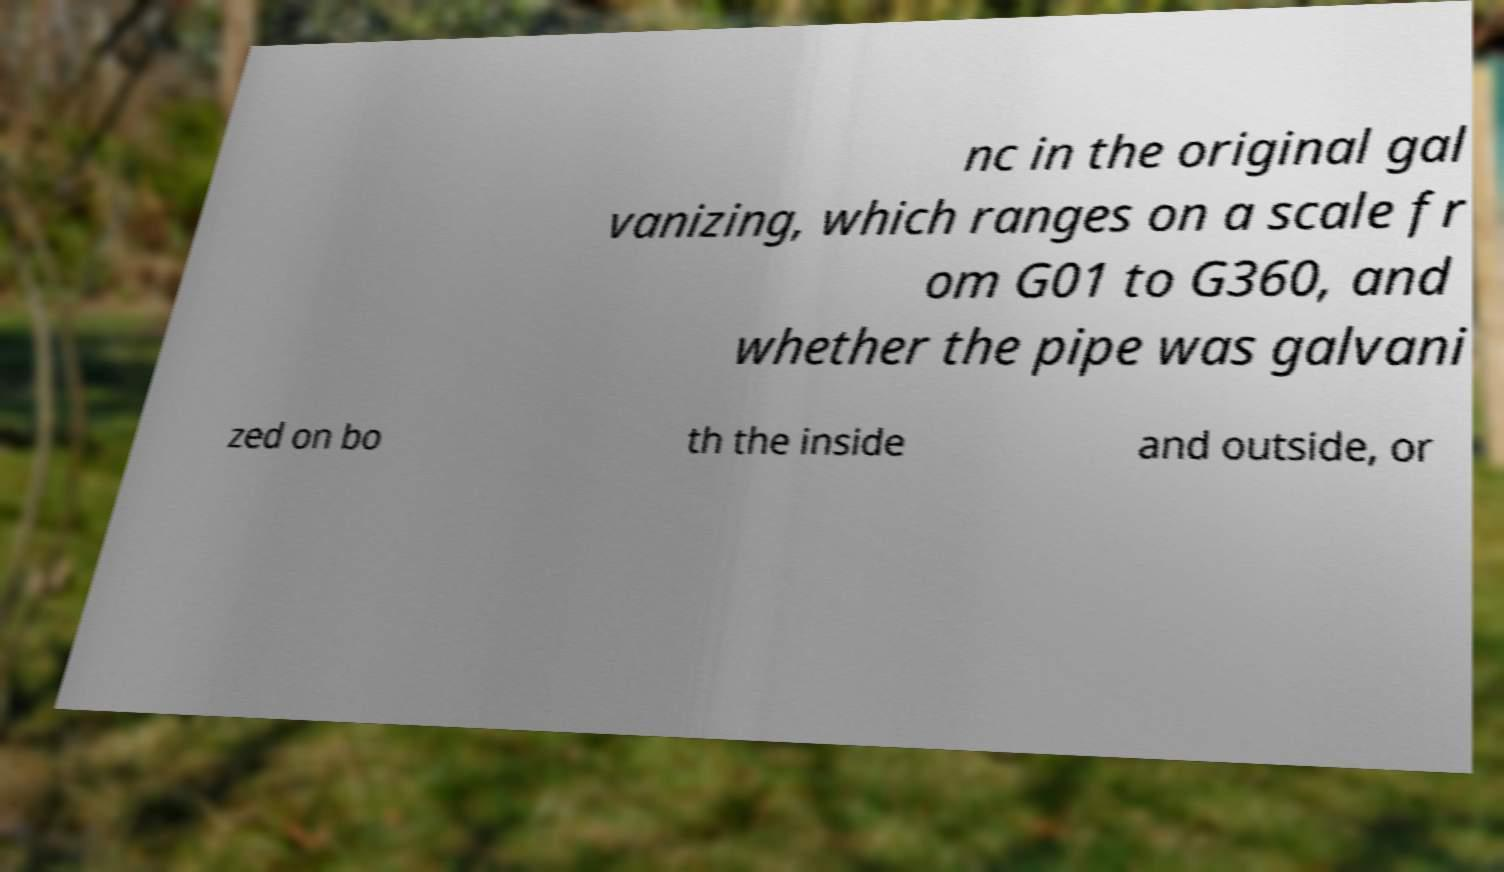Could you assist in decoding the text presented in this image and type it out clearly? nc in the original gal vanizing, which ranges on a scale fr om G01 to G360, and whether the pipe was galvani zed on bo th the inside and outside, or 